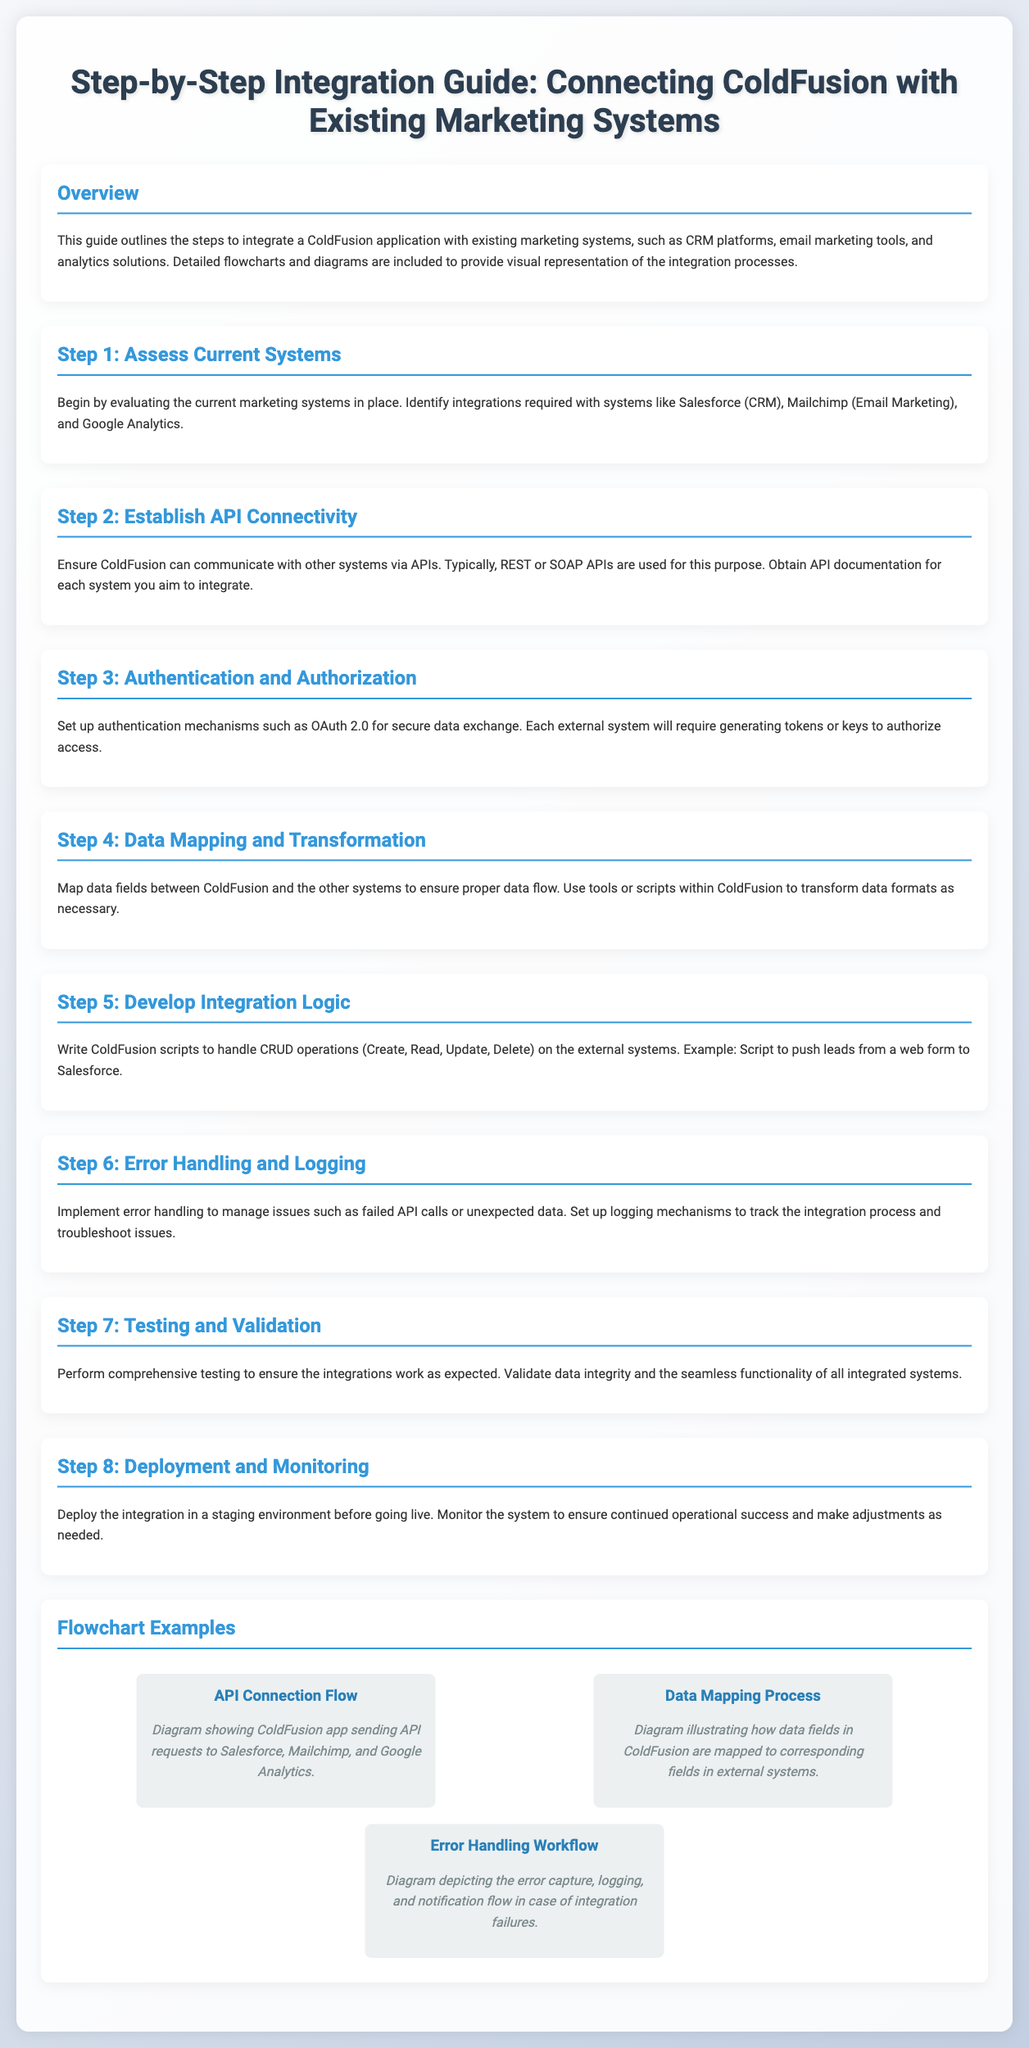What is the title of the guide? The title is prominently displayed at the top of the document, indicating its purpose and focus.
Answer: Step-by-Step Integration Guide: Connecting ColdFusion with Existing Marketing Systems What is the first step in the integration process? The document outlines the steps in a sequential manner, beginning with the first step being assessed.
Answer: Assess Current Systems Which authentication mechanism is suggested? The document specifically mentions a mechanism for secure data exchange in the integration process.
Answer: OAuth 2.0 How many steps are there in the integration process? The document lists a total of eight distinct steps involved in the integration process.
Answer: 8 What diagram is associated with error handling? The document describes various diagrams related to different aspects of the integration process, including error management.
Answer: Error Handling Workflow What are the systems mentioned for integration? The document provides examples of marketing systems that need to be integrated with ColdFusion applications.
Answer: Salesforce, Mailchimp, Google Analytics What does the API Connection Flow diagram illustrate? The diagram provides a visual representation of the data flow between the ColdFusion application and external systems.
Answer: ColdFusion app sending API requests to Salesforce, Mailchimp, and Google Analytics What is the purpose of deploying the integration in a staging environment? The document briefly covers deployment strategies, particularly mentioning the importance of testing prior to going live.
Answer: Testing before going live 